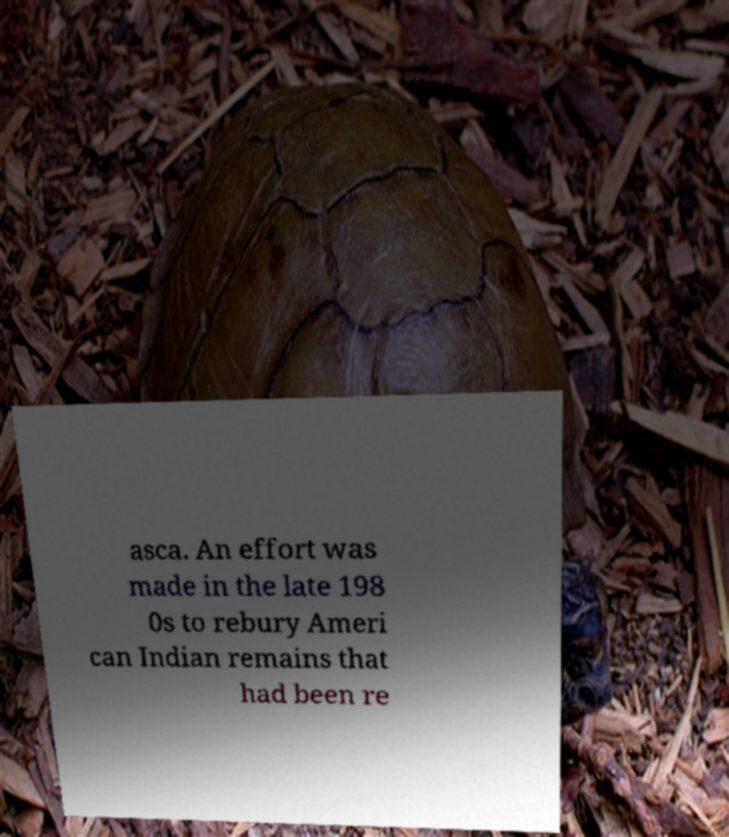Could you assist in decoding the text presented in this image and type it out clearly? asca. An effort was made in the late 198 0s to rebury Ameri can Indian remains that had been re 